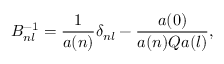Convert formula to latex. <formula><loc_0><loc_0><loc_500><loc_500>B _ { n l } ^ { - 1 } = \frac { 1 } { a ( n ) } \delta _ { n l } - \frac { a ( 0 ) } { a ( n ) Q a ( l ) } ,</formula> 